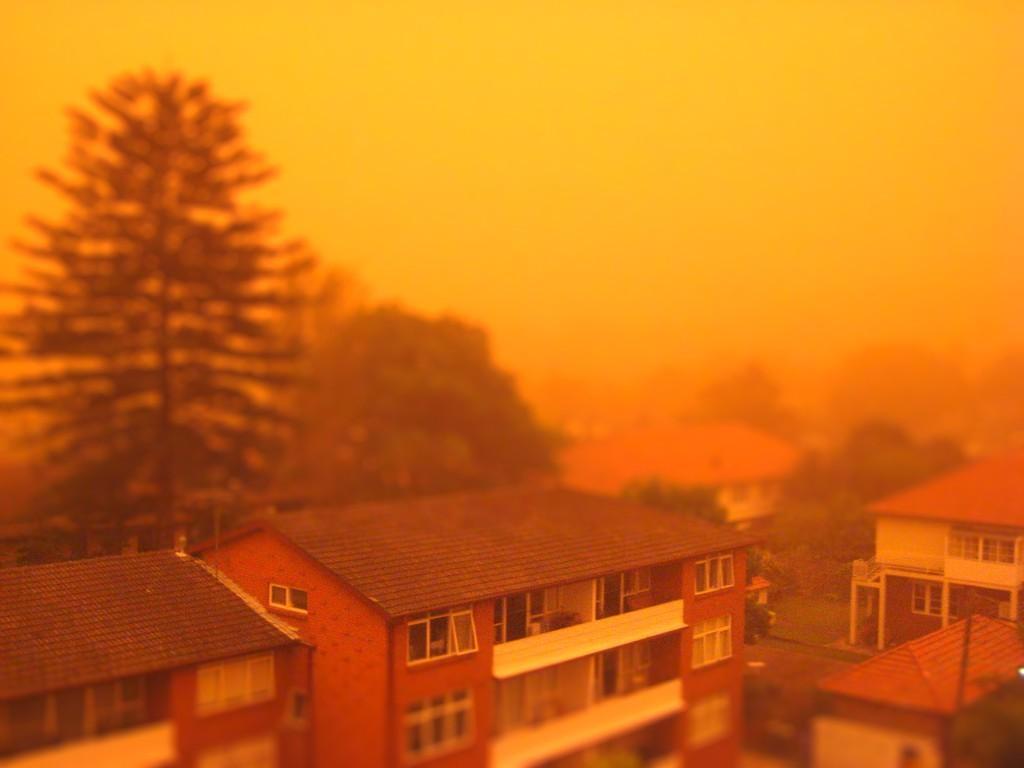Describe this image in one or two sentences. In this image there is the sky truncated towards the top of the image, there are trees, there are houses, there are houses truncated towards the right of the image, there are houses truncated towards the bottom of the image, there is a house truncated towards the left of the image, there are windows. 